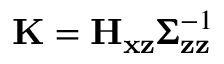<formula> <loc_0><loc_0><loc_500><loc_500>K = H _ { x z } \pm b { \Sigma } _ { z z } ^ { - 1 }</formula> 